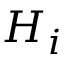Convert formula to latex. <formula><loc_0><loc_0><loc_500><loc_500>H _ { i }</formula> 